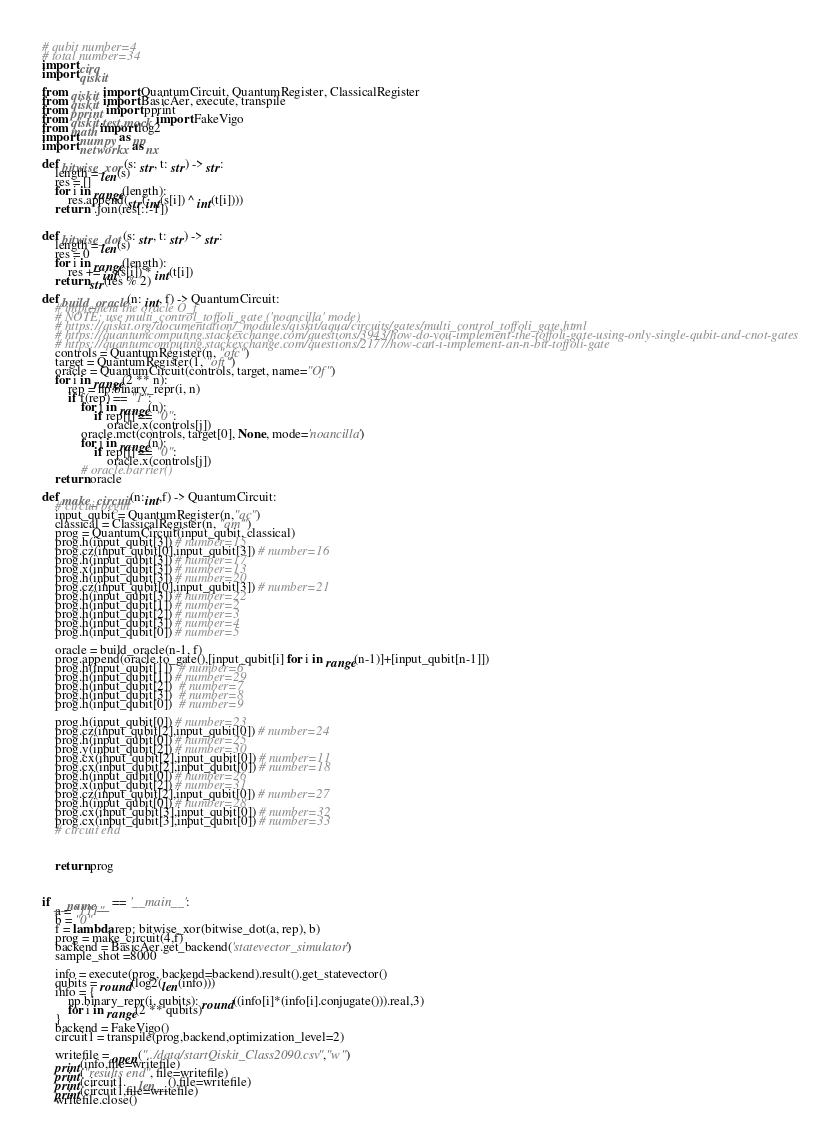<code> <loc_0><loc_0><loc_500><loc_500><_Python_># qubit number=4
# total number=34
import cirq
import qiskit

from qiskit import QuantumCircuit, QuantumRegister, ClassicalRegister
from qiskit import BasicAer, execute, transpile
from pprint import pprint
from qiskit.test.mock import FakeVigo
from math import log2
import numpy as np
import networkx as nx

def bitwise_xor(s: str, t: str) -> str:
    length = len(s)
    res = []
    for i in range(length):
        res.append(str(int(s[i]) ^ int(t[i])))
    return ''.join(res[::-1])


def bitwise_dot(s: str, t: str) -> str:
    length = len(s)
    res = 0
    for i in range(length):
        res += int(s[i]) * int(t[i])
    return str(res % 2)

def build_oracle(n: int, f) -> QuantumCircuit:
    # implement the oracle O_f
    # NOTE: use multi_control_toffoli_gate ('noancilla' mode)
    # https://qiskit.org/documentation/_modules/qiskit/aqua/circuits/gates/multi_control_toffoli_gate.html
    # https://quantumcomputing.stackexchange.com/questions/3943/how-do-you-implement-the-toffoli-gate-using-only-single-qubit-and-cnot-gates
    # https://quantumcomputing.stackexchange.com/questions/2177/how-can-i-implement-an-n-bit-toffoli-gate
    controls = QuantumRegister(n, "ofc")
    target = QuantumRegister(1, "oft")
    oracle = QuantumCircuit(controls, target, name="Of")
    for i in range(2 ** n):
        rep = np.binary_repr(i, n)
        if f(rep) == "1":
            for j in range(n):
                if rep[j] == "0":
                    oracle.x(controls[j])
            oracle.mct(controls, target[0], None, mode='noancilla')
            for j in range(n):
                if rep[j] == "0":
                    oracle.x(controls[j])
            # oracle.barrier()
    return oracle

def make_circuit(n:int,f) -> QuantumCircuit:
    # circuit begin
    input_qubit = QuantumRegister(n,"qc")
    classical = ClassicalRegister(n, "qm")
    prog = QuantumCircuit(input_qubit, classical)
    prog.h(input_qubit[3]) # number=15
    prog.cz(input_qubit[0],input_qubit[3]) # number=16
    prog.h(input_qubit[3]) # number=17
    prog.x(input_qubit[3]) # number=13
    prog.h(input_qubit[3]) # number=20
    prog.cz(input_qubit[0],input_qubit[3]) # number=21
    prog.h(input_qubit[3]) # number=22
    prog.h(input_qubit[1]) # number=2
    prog.h(input_qubit[2]) # number=3
    prog.h(input_qubit[3]) # number=4
    prog.h(input_qubit[0]) # number=5

    oracle = build_oracle(n-1, f)
    prog.append(oracle.to_gate(),[input_qubit[i] for i in range(n-1)]+[input_qubit[n-1]])
    prog.h(input_qubit[1])  # number=6
    prog.h(input_qubit[1]) # number=29
    prog.h(input_qubit[2])  # number=7
    prog.h(input_qubit[3])  # number=8
    prog.h(input_qubit[0])  # number=9

    prog.h(input_qubit[0]) # number=23
    prog.cz(input_qubit[2],input_qubit[0]) # number=24
    prog.h(input_qubit[0]) # number=25
    prog.y(input_qubit[2]) # number=30
    prog.cx(input_qubit[2],input_qubit[0]) # number=11
    prog.cx(input_qubit[2],input_qubit[0]) # number=18
    prog.h(input_qubit[0]) # number=26
    prog.x(input_qubit[2]) # number=31
    prog.cz(input_qubit[2],input_qubit[0]) # number=27
    prog.h(input_qubit[0]) # number=28
    prog.cx(input_qubit[3],input_qubit[0]) # number=32
    prog.cx(input_qubit[3],input_qubit[0]) # number=33
    # circuit end



    return prog



if __name__ == '__main__':
    a = "111"
    b = "0"
    f = lambda rep: bitwise_xor(bitwise_dot(a, rep), b)
    prog = make_circuit(4,f)
    backend = BasicAer.get_backend('statevector_simulator')
    sample_shot =8000

    info = execute(prog, backend=backend).result().get_statevector()
    qubits = round(log2(len(info)))
    info = {
        np.binary_repr(i, qubits): round((info[i]*(info[i].conjugate())).real,3)
        for i in range(2 ** qubits)
    }
    backend = FakeVigo()
    circuit1 = transpile(prog,backend,optimization_level=2)

    writefile = open("../data/startQiskit_Class2090.csv","w")
    print(info,file=writefile)
    print("results end", file=writefile)
    print(circuit1.__len__(),file=writefile)
    print(circuit1,file=writefile)
    writefile.close()
</code> 